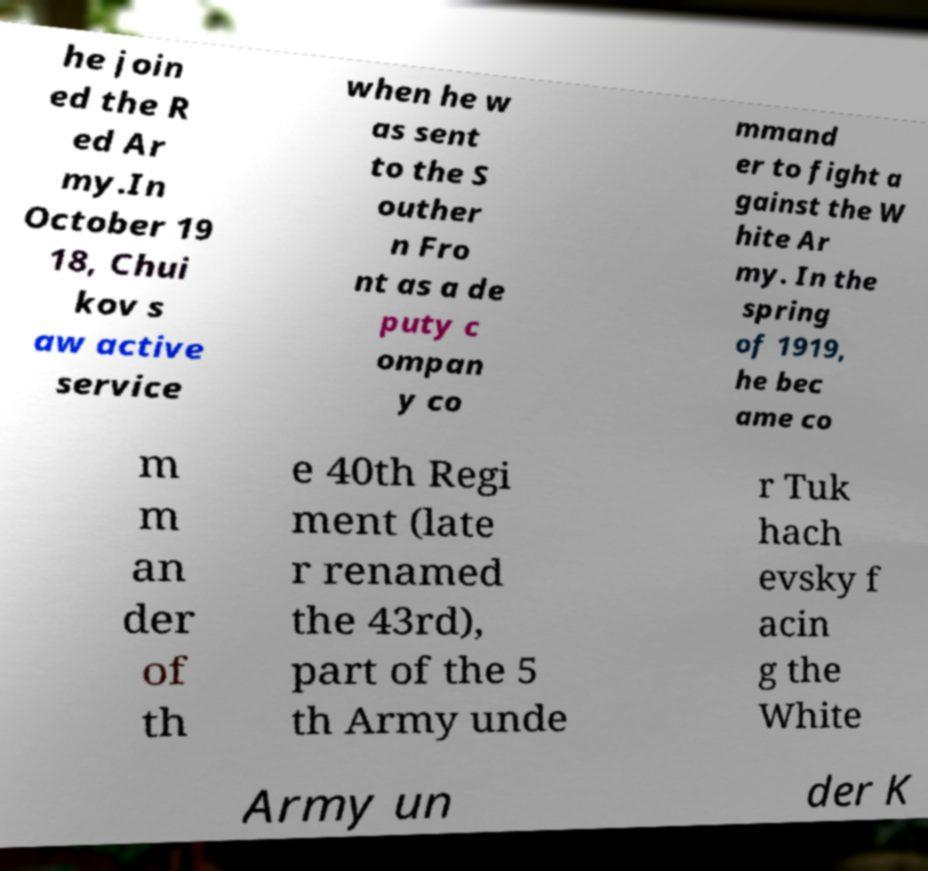Please identify and transcribe the text found in this image. he join ed the R ed Ar my.In October 19 18, Chui kov s aw active service when he w as sent to the S outher n Fro nt as a de puty c ompan y co mmand er to fight a gainst the W hite Ar my. In the spring of 1919, he bec ame co m m an der of th e 40th Regi ment (late r renamed the 43rd), part of the 5 th Army unde r Tuk hach evsky f acin g the White Army un der K 